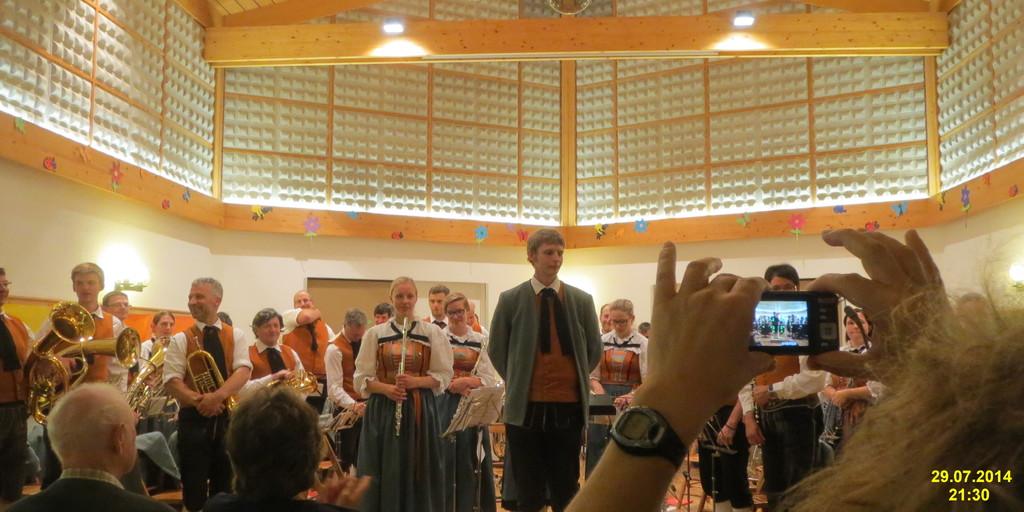What date is this?
Offer a very short reply. 29.07.2014. 